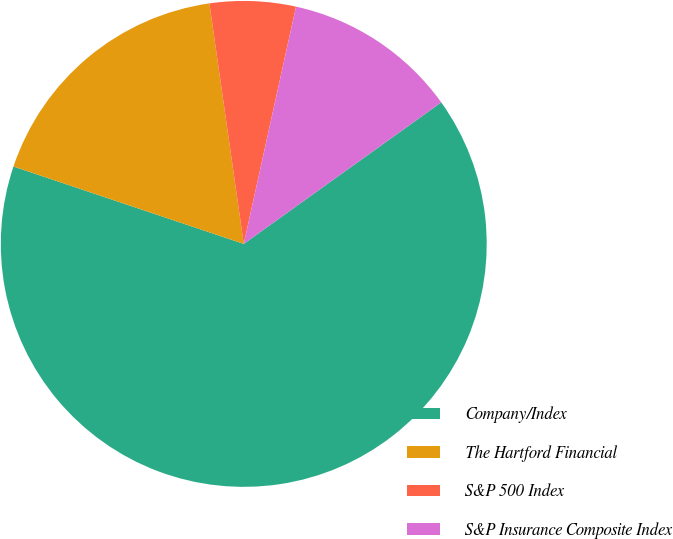Convert chart to OTSL. <chart><loc_0><loc_0><loc_500><loc_500><pie_chart><fcel>Company/Index<fcel>The Hartford Financial<fcel>S&P 500 Index<fcel>S&P Insurance Composite Index<nl><fcel>65.05%<fcel>17.58%<fcel>5.71%<fcel>11.65%<nl></chart> 